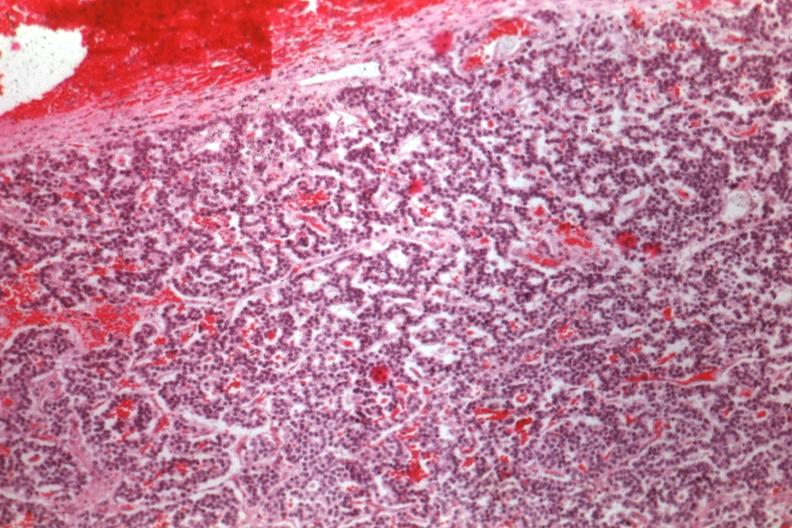what is present?
Answer the question using a single word or phrase. Chromophobe adenoma 